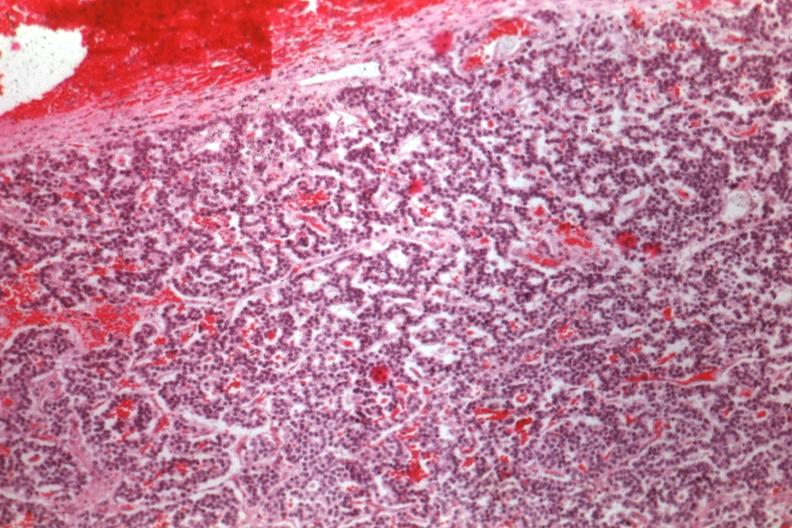what is present?
Answer the question using a single word or phrase. Chromophobe adenoma 